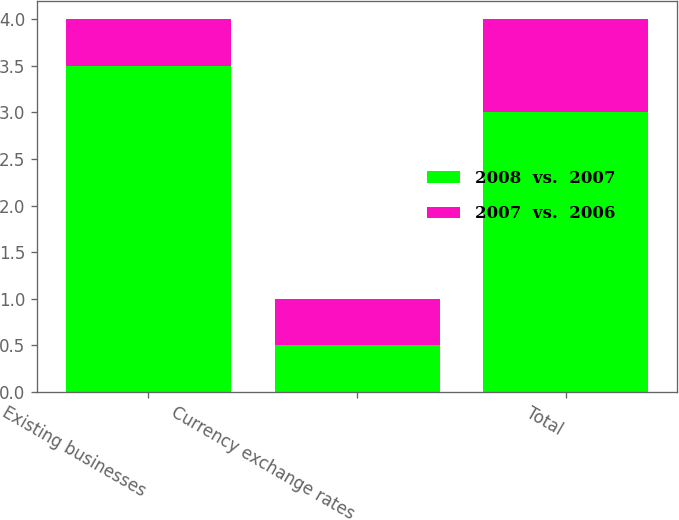<chart> <loc_0><loc_0><loc_500><loc_500><stacked_bar_chart><ecel><fcel>Existing businesses<fcel>Currency exchange rates<fcel>Total<nl><fcel>2008  vs.  2007<fcel>3.5<fcel>0.5<fcel>3<nl><fcel>2007  vs.  2006<fcel>0.5<fcel>0.5<fcel>1<nl></chart> 